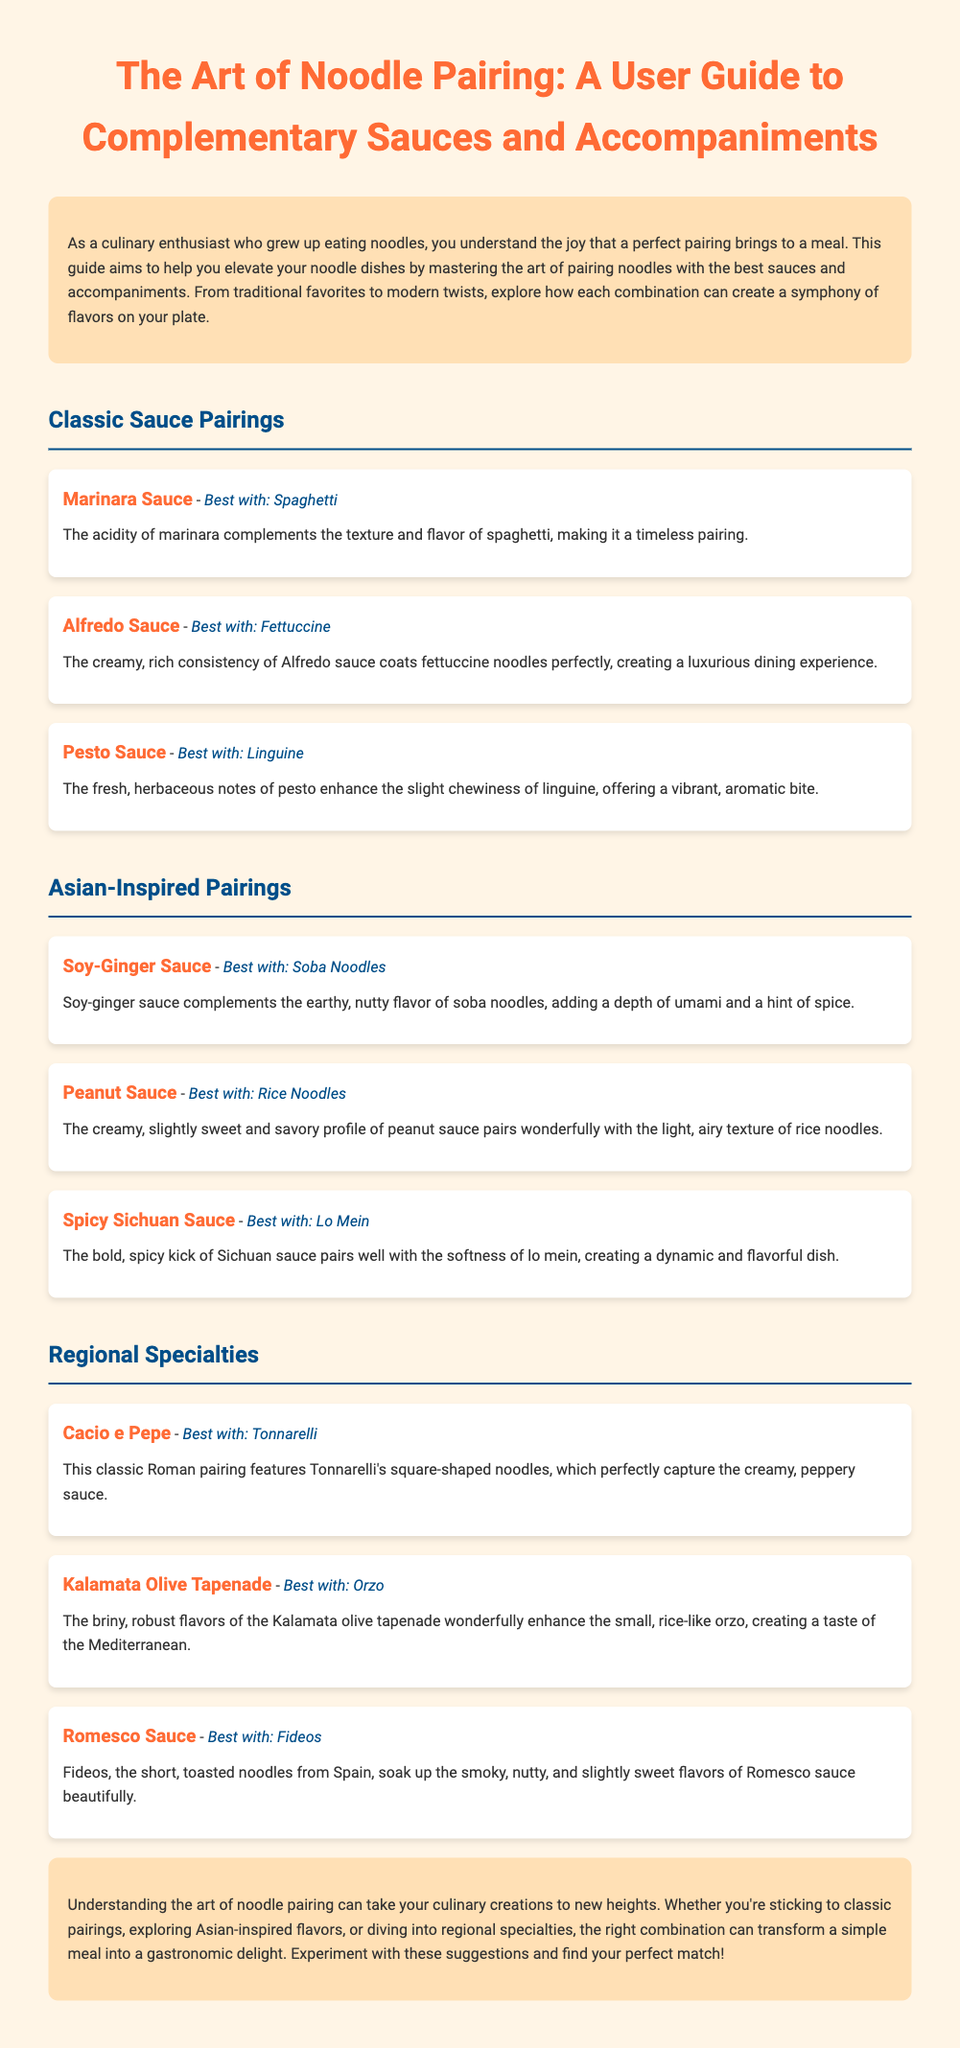what is the title of the document? The title of the document is presented prominently at the top of the guide.
Answer: The Art of Noodle Pairing: A User Guide to Complementary Sauces and Accompaniments which sauce is best with spaghetti? The document lists sauces alongside the noodles they pair best with.
Answer: Marinara Sauce what sauce complements soba noodles? The document provides specific pairings for different noodles.
Answer: Soy-Ginger Sauce how many classic sauce pairings are listed? The document outlines various sauce pairings grouped into different sections.
Answer: Three which two noodles are paired with sauces from Asian-inspired pairings? By examining the Asian-Inspired Pairings section, we can find noodles paired with sauces.
Answer: Soba Noodles, Rice Noodles what is the primary theme of the introduction? The introduction sets the stage for the content of the guide, focusing on improving culinary skills.
Answer: Elevated noodle dishes what region is associated with Cacio e Pepe? The document includes a section on regional specialties and their associations.
Answer: Roman what is the purpose of this user guide? The document specifies its aim in the introduction section.
Answer: Help elevate noodle dishes which sauce is paired with fideos? By looking in the Regional Specialties section, we can find the suggested pairing.
Answer: Romesco Sauce 